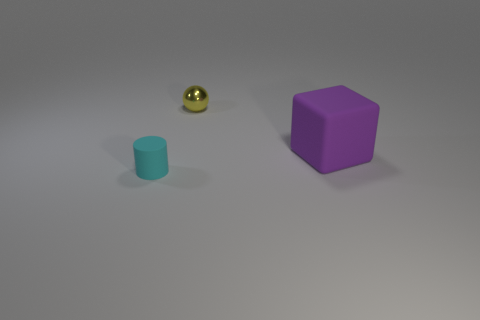There is a thing in front of the large purple matte cube; how big is it?
Your answer should be very brief. Small. What size is the metal ball?
Your response must be concise. Small. There is a cyan cylinder; does it have the same size as the matte thing right of the sphere?
Ensure brevity in your answer.  No. What color is the small object in front of the tiny thing behind the rubber cylinder?
Offer a very short reply. Cyan. Are there an equal number of balls that are behind the tiny metal sphere and cylinders in front of the cyan object?
Offer a terse response. Yes. Do the tiny thing that is behind the tiny matte thing and the purple thing have the same material?
Offer a very short reply. No. What is the color of the object that is both in front of the tiny metallic sphere and on the right side of the small cyan matte cylinder?
Your response must be concise. Purple. What number of small things are right of the thing in front of the purple block?
Your answer should be compact. 1. What is the color of the tiny sphere?
Your answer should be very brief. Yellow. How many objects are big brown metallic cubes or cyan rubber objects?
Your response must be concise. 1. 